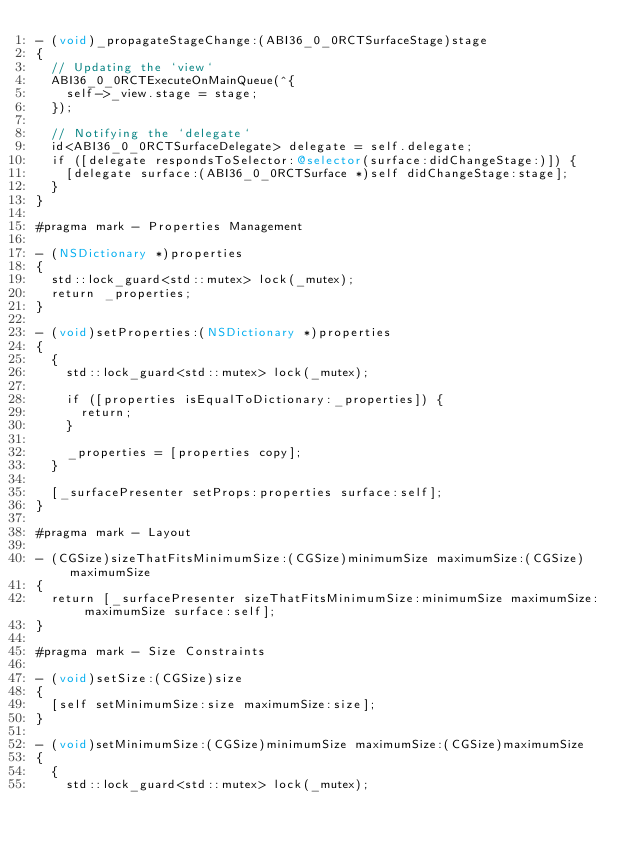<code> <loc_0><loc_0><loc_500><loc_500><_ObjectiveC_>- (void)_propagateStageChange:(ABI36_0_0RCTSurfaceStage)stage
{
  // Updating the `view`
  ABI36_0_0RCTExecuteOnMainQueue(^{
    self->_view.stage = stage;
  });

  // Notifying the `delegate`
  id<ABI36_0_0RCTSurfaceDelegate> delegate = self.delegate;
  if ([delegate respondsToSelector:@selector(surface:didChangeStage:)]) {
    [delegate surface:(ABI36_0_0RCTSurface *)self didChangeStage:stage];
  }
}

#pragma mark - Properties Management

- (NSDictionary *)properties
{
  std::lock_guard<std::mutex> lock(_mutex);
  return _properties;
}

- (void)setProperties:(NSDictionary *)properties
{
  {
    std::lock_guard<std::mutex> lock(_mutex);

    if ([properties isEqualToDictionary:_properties]) {
      return;
    }

    _properties = [properties copy];
  }

  [_surfacePresenter setProps:properties surface:self];
}

#pragma mark - Layout

- (CGSize)sizeThatFitsMinimumSize:(CGSize)minimumSize maximumSize:(CGSize)maximumSize
{
  return [_surfacePresenter sizeThatFitsMinimumSize:minimumSize maximumSize:maximumSize surface:self];
}

#pragma mark - Size Constraints

- (void)setSize:(CGSize)size
{
  [self setMinimumSize:size maximumSize:size];
}

- (void)setMinimumSize:(CGSize)minimumSize maximumSize:(CGSize)maximumSize
{
  {
    std::lock_guard<std::mutex> lock(_mutex);</code> 